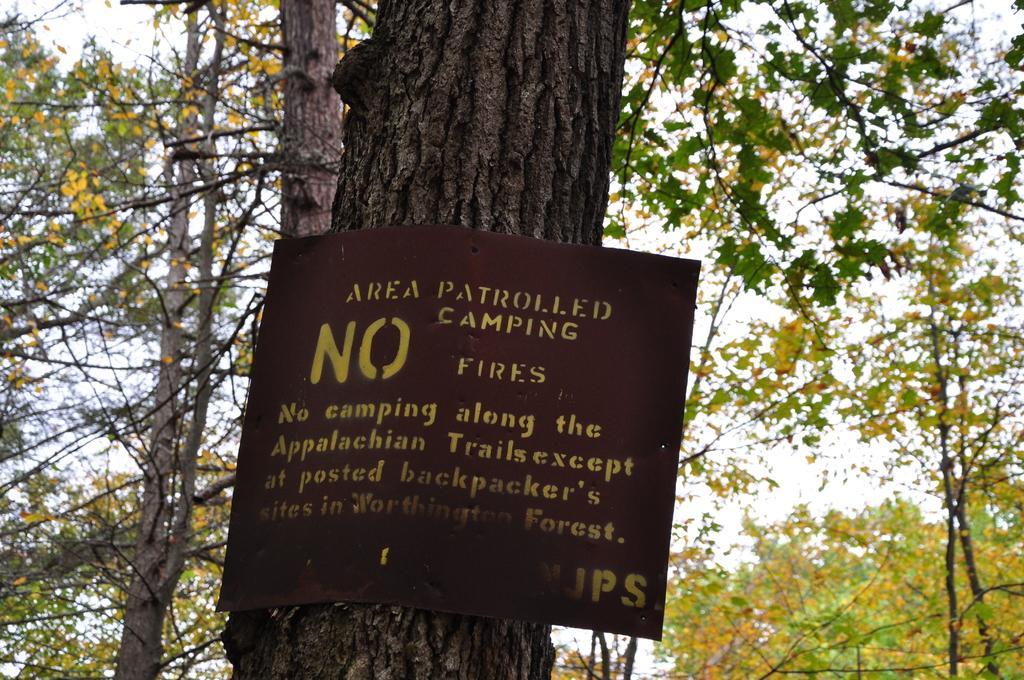Could you give a brief overview of what you see in this image? In this picture, we can see some trees, a poster with some text on it. 